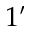<formula> <loc_0><loc_0><loc_500><loc_500>1 ^ { \prime }</formula> 